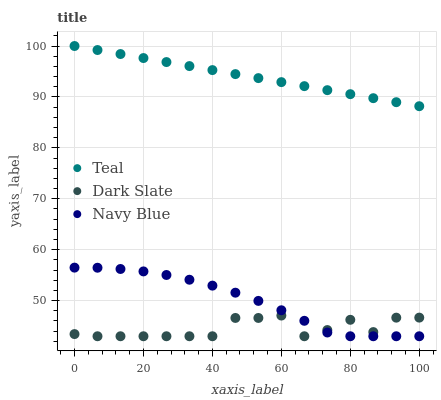Does Dark Slate have the minimum area under the curve?
Answer yes or no. Yes. Does Teal have the maximum area under the curve?
Answer yes or no. Yes. Does Navy Blue have the minimum area under the curve?
Answer yes or no. No. Does Navy Blue have the maximum area under the curve?
Answer yes or no. No. Is Teal the smoothest?
Answer yes or no. Yes. Is Dark Slate the roughest?
Answer yes or no. Yes. Is Navy Blue the smoothest?
Answer yes or no. No. Is Navy Blue the roughest?
Answer yes or no. No. Does Dark Slate have the lowest value?
Answer yes or no. Yes. Does Teal have the lowest value?
Answer yes or no. No. Does Teal have the highest value?
Answer yes or no. Yes. Does Navy Blue have the highest value?
Answer yes or no. No. Is Navy Blue less than Teal?
Answer yes or no. Yes. Is Teal greater than Dark Slate?
Answer yes or no. Yes. Does Dark Slate intersect Navy Blue?
Answer yes or no. Yes. Is Dark Slate less than Navy Blue?
Answer yes or no. No. Is Dark Slate greater than Navy Blue?
Answer yes or no. No. Does Navy Blue intersect Teal?
Answer yes or no. No. 